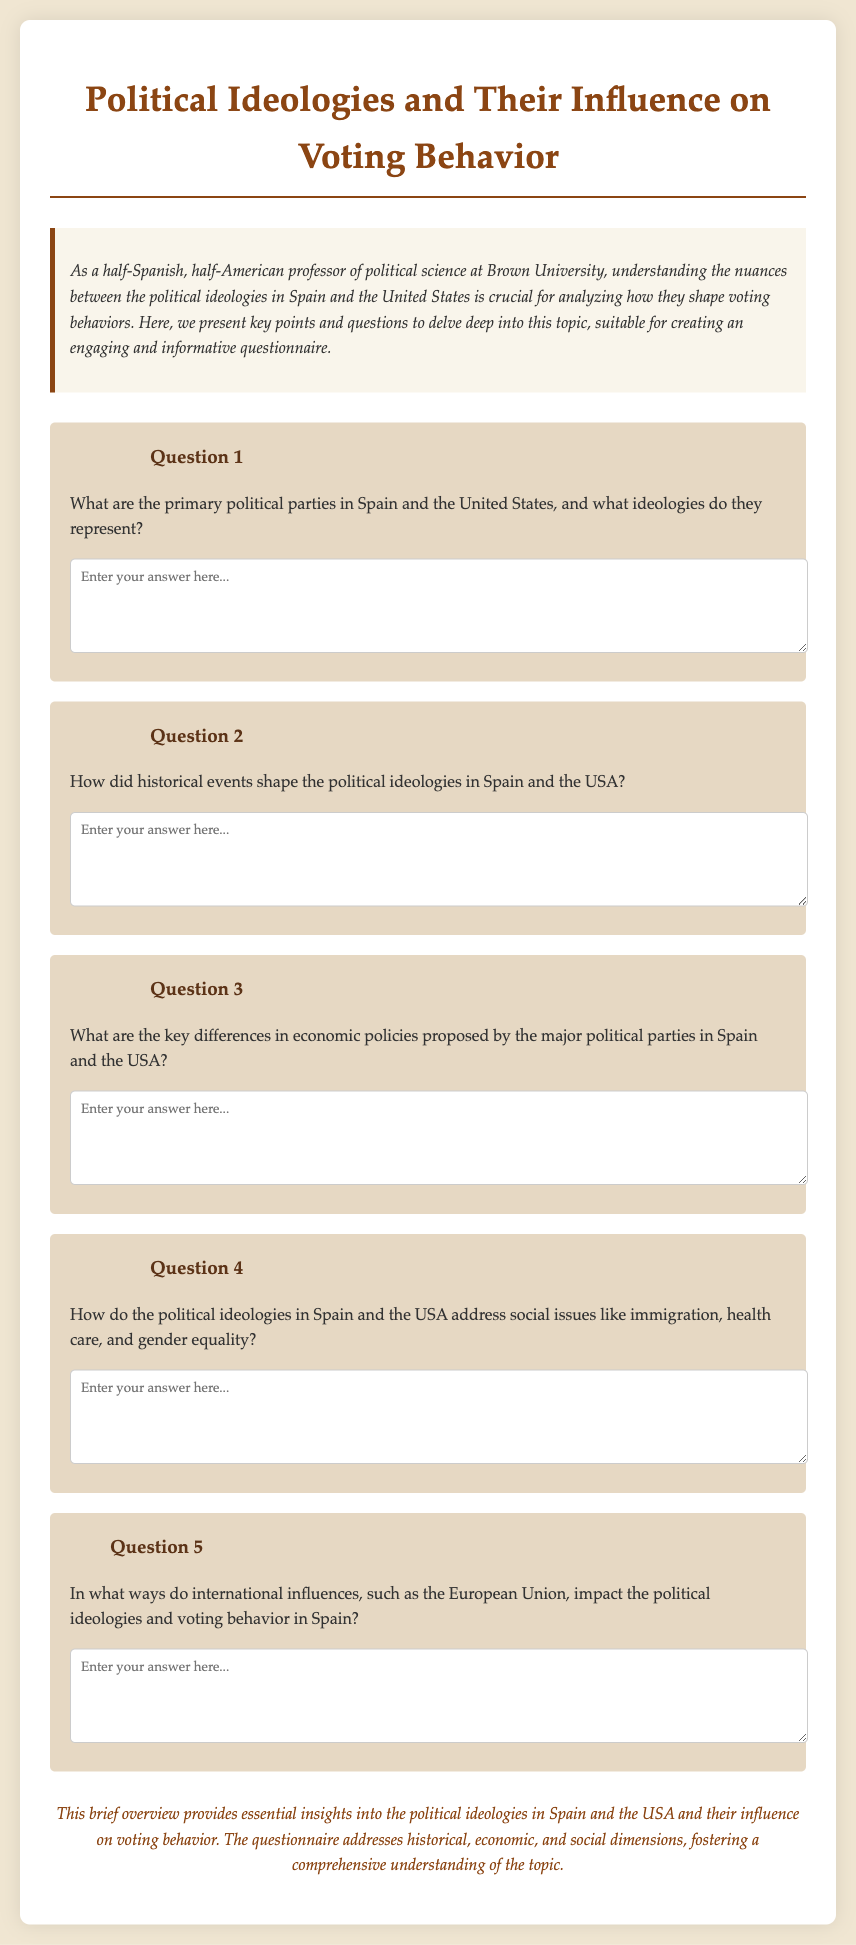What is the title of the document? The title is located in the header of the document.
Answer: Political Ideologies and Their Influence on Voting Behavior How many main questions are included in the document? The document lists five main questions under the title.
Answer: 5 What ideologies is the document primarily concerned with? The ideologies discussed revolve around Spain and the United States, as indicated in the introduction.
Answer: Spain and the United States What are the two countries analyzed in the questionnaire? The introduction explicitly states the two countries being analyzed.
Answer: Spain and the United States Which political and social issues does the document suggest are addressed by the ideologies in both countries? The document mentions immigration, health care, and gender equality as social issues addressed by the ideologies.
Answer: Immigration, health care, and gender equality What type of questions does this questionnaire consist of? The introduction describes the questionnaire focusing on understanding political ideologies and their influence on voting behavior.
Answer: Short-answer questions What additional influence on Spain's political ideologies is mentioned? The document refers to the impact of the European Union on Spain's political ideologies.
Answer: European Union What is emphasized as crucial for analyzing voting behavior in the introduction? The need to understand the nuances between the political ideologies in the two countries is emphasized as crucial.
Answer: Understanding the nuances between the political ideologies 